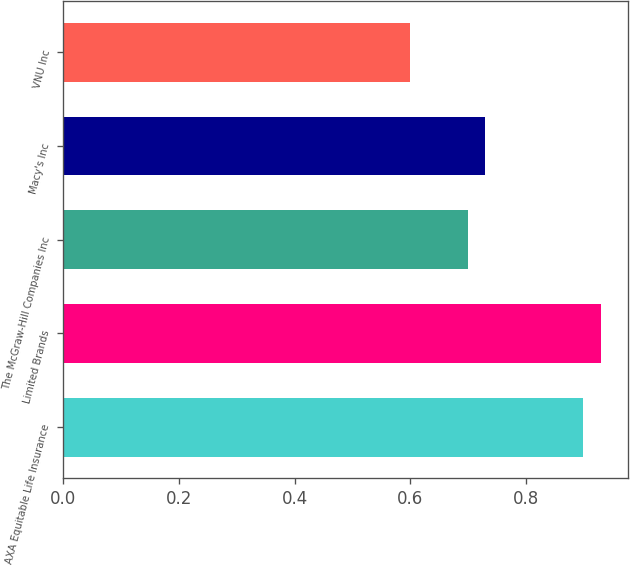Convert chart. <chart><loc_0><loc_0><loc_500><loc_500><bar_chart><fcel>AXA Equitable Life Insurance<fcel>Limited Brands<fcel>The McGraw-Hill Companies Inc<fcel>Macy's Inc<fcel>VNU Inc<nl><fcel>0.9<fcel>0.93<fcel>0.7<fcel>0.73<fcel>0.6<nl></chart> 